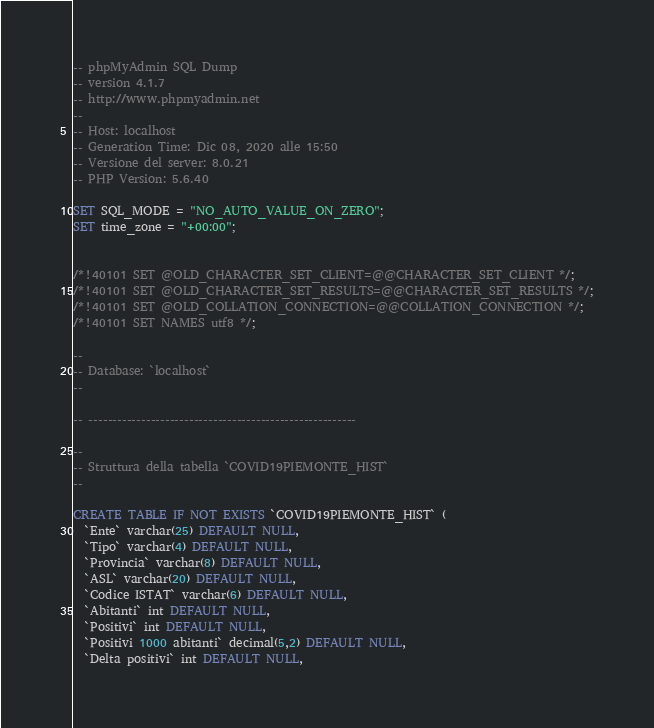<code> <loc_0><loc_0><loc_500><loc_500><_SQL_>-- phpMyAdmin SQL Dump
-- version 4.1.7
-- http://www.phpmyadmin.net
--
-- Host: localhost
-- Generation Time: Dic 08, 2020 alle 15:50
-- Versione del server: 8.0.21
-- PHP Version: 5.6.40

SET SQL_MODE = "NO_AUTO_VALUE_ON_ZERO";
SET time_zone = "+00:00";


/*!40101 SET @OLD_CHARACTER_SET_CLIENT=@@CHARACTER_SET_CLIENT */;
/*!40101 SET @OLD_CHARACTER_SET_RESULTS=@@CHARACTER_SET_RESULTS */;
/*!40101 SET @OLD_COLLATION_CONNECTION=@@COLLATION_CONNECTION */;
/*!40101 SET NAMES utf8 */;

--
-- Database: `localhost`
--

-- --------------------------------------------------------

--
-- Struttura della tabella `COVID19PIEMONTE_HIST`
--

CREATE TABLE IF NOT EXISTS `COVID19PIEMONTE_HIST` (
  `Ente` varchar(25) DEFAULT NULL,
  `Tipo` varchar(4) DEFAULT NULL,
  `Provincia` varchar(8) DEFAULT NULL,
  `ASL` varchar(20) DEFAULT NULL,
  `Codice ISTAT` varchar(6) DEFAULT NULL,
  `Abitanti` int DEFAULT NULL,
  `Positivi` int DEFAULT NULL,
  `Positivi 1000 abitanti` decimal(5,2) DEFAULT NULL,
  `Delta positivi` int DEFAULT NULL,</code> 